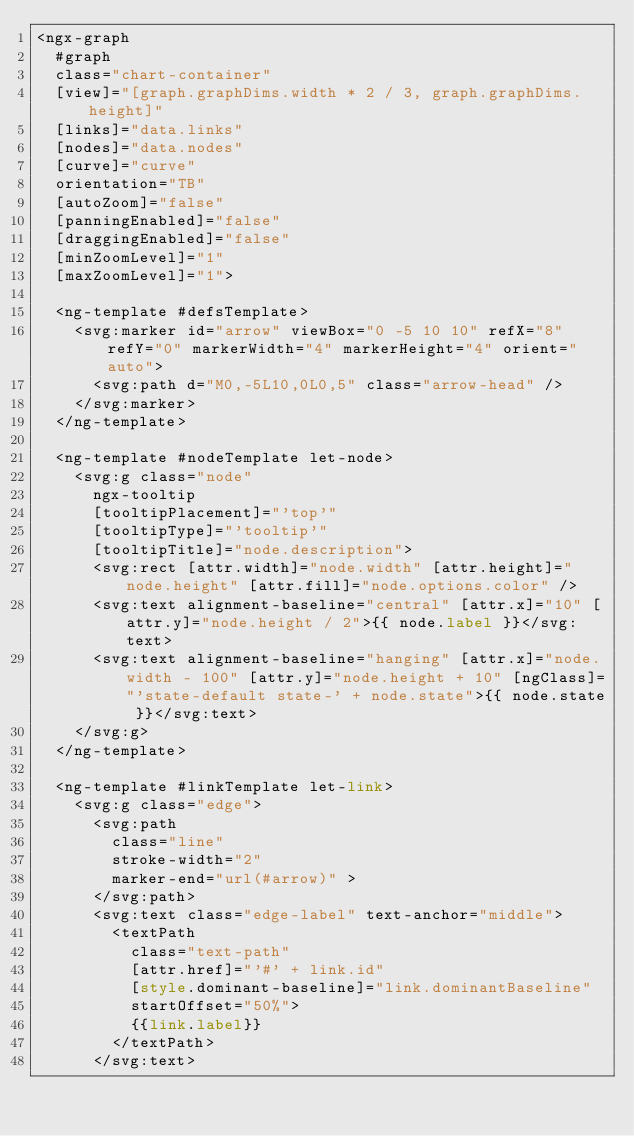<code> <loc_0><loc_0><loc_500><loc_500><_HTML_><ngx-graph
  #graph
  class="chart-container"
  [view]="[graph.graphDims.width * 2 / 3, graph.graphDims.height]"
  [links]="data.links"
  [nodes]="data.nodes"
  [curve]="curve"
  orientation="TB"
  [autoZoom]="false"
  [panningEnabled]="false"
  [draggingEnabled]="false"
  [minZoomLevel]="1"
  [maxZoomLevel]="1">

  <ng-template #defsTemplate>
    <svg:marker id="arrow" viewBox="0 -5 10 10" refX="8" refY="0" markerWidth="4" markerHeight="4" orient="auto">
      <svg:path d="M0,-5L10,0L0,5" class="arrow-head" />
    </svg:marker>
  </ng-template>

  <ng-template #nodeTemplate let-node>
    <svg:g class="node"
      ngx-tooltip
      [tooltipPlacement]="'top'"
      [tooltipType]="'tooltip'"
      [tooltipTitle]="node.description">
      <svg:rect [attr.width]="node.width" [attr.height]="node.height" [attr.fill]="node.options.color" />
      <svg:text alignment-baseline="central" [attr.x]="10" [attr.y]="node.height / 2">{{ node.label }}</svg:text>
      <svg:text alignment-baseline="hanging" [attr.x]="node.width - 100" [attr.y]="node.height + 10" [ngClass]="'state-default state-' + node.state">{{ node.state }}</svg:text>
    </svg:g>
  </ng-template>

  <ng-template #linkTemplate let-link>
    <svg:g class="edge">
      <svg:path
        class="line"
        stroke-width="2"
        marker-end="url(#arrow)" >
      </svg:path>
      <svg:text class="edge-label" text-anchor="middle">
        <textPath
          class="text-path"
          [attr.href]="'#' + link.id"
          [style.dominant-baseline]="link.dominantBaseline"
          startOffset="50%">
          {{link.label}}
        </textPath>
      </svg:text></code> 